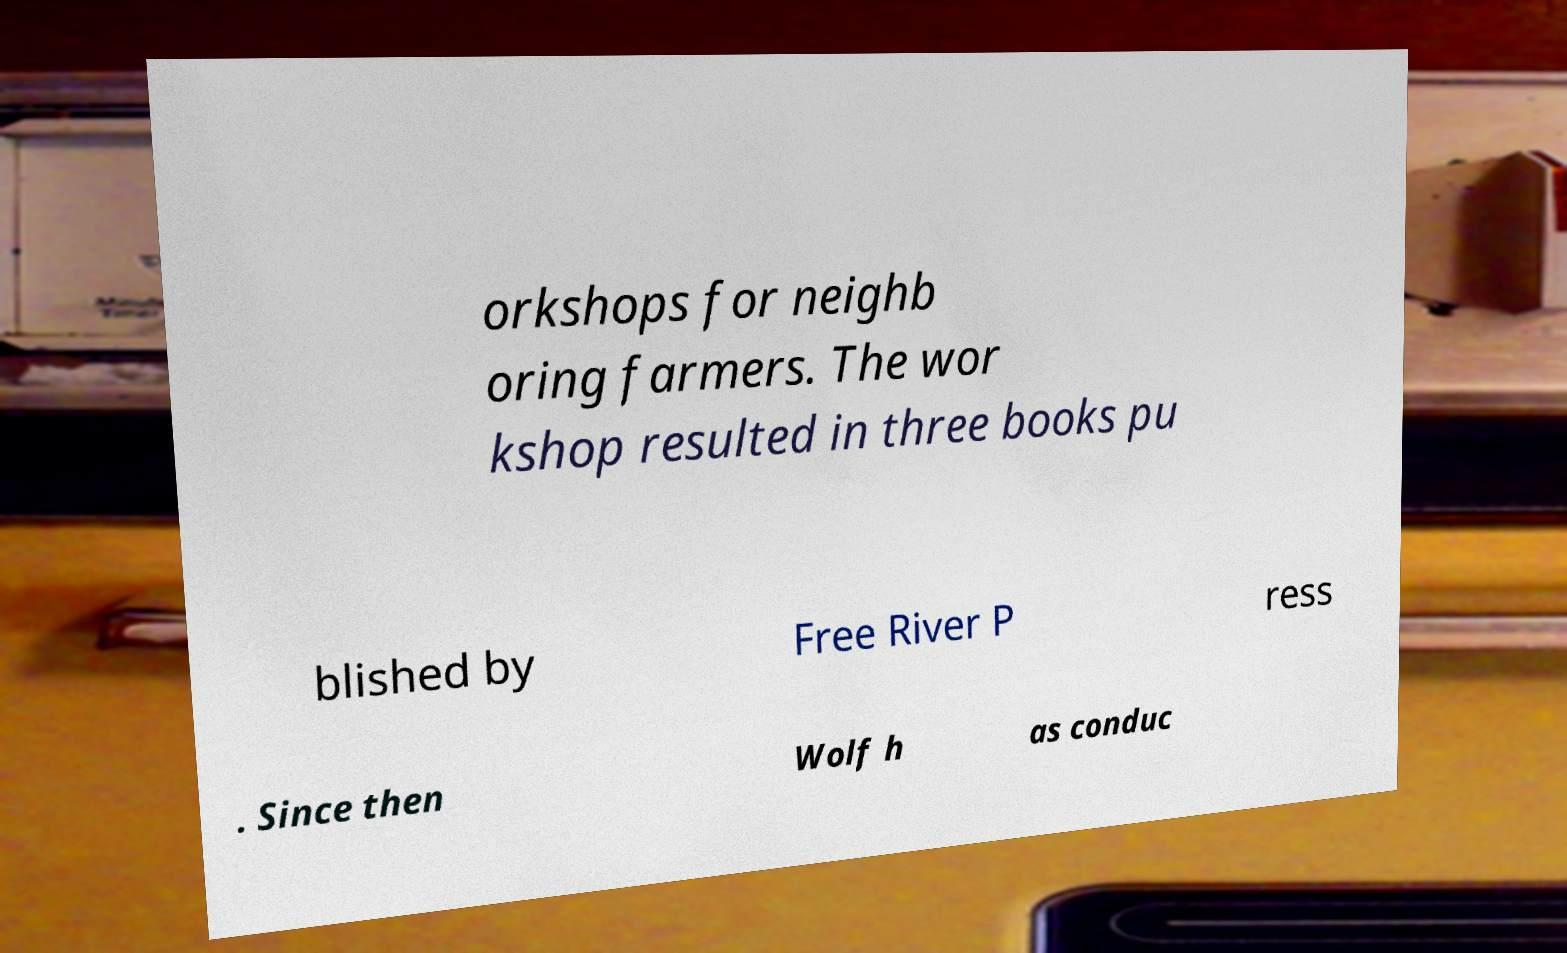Please read and relay the text visible in this image. What does it say? orkshops for neighb oring farmers. The wor kshop resulted in three books pu blished by Free River P ress . Since then Wolf h as conduc 